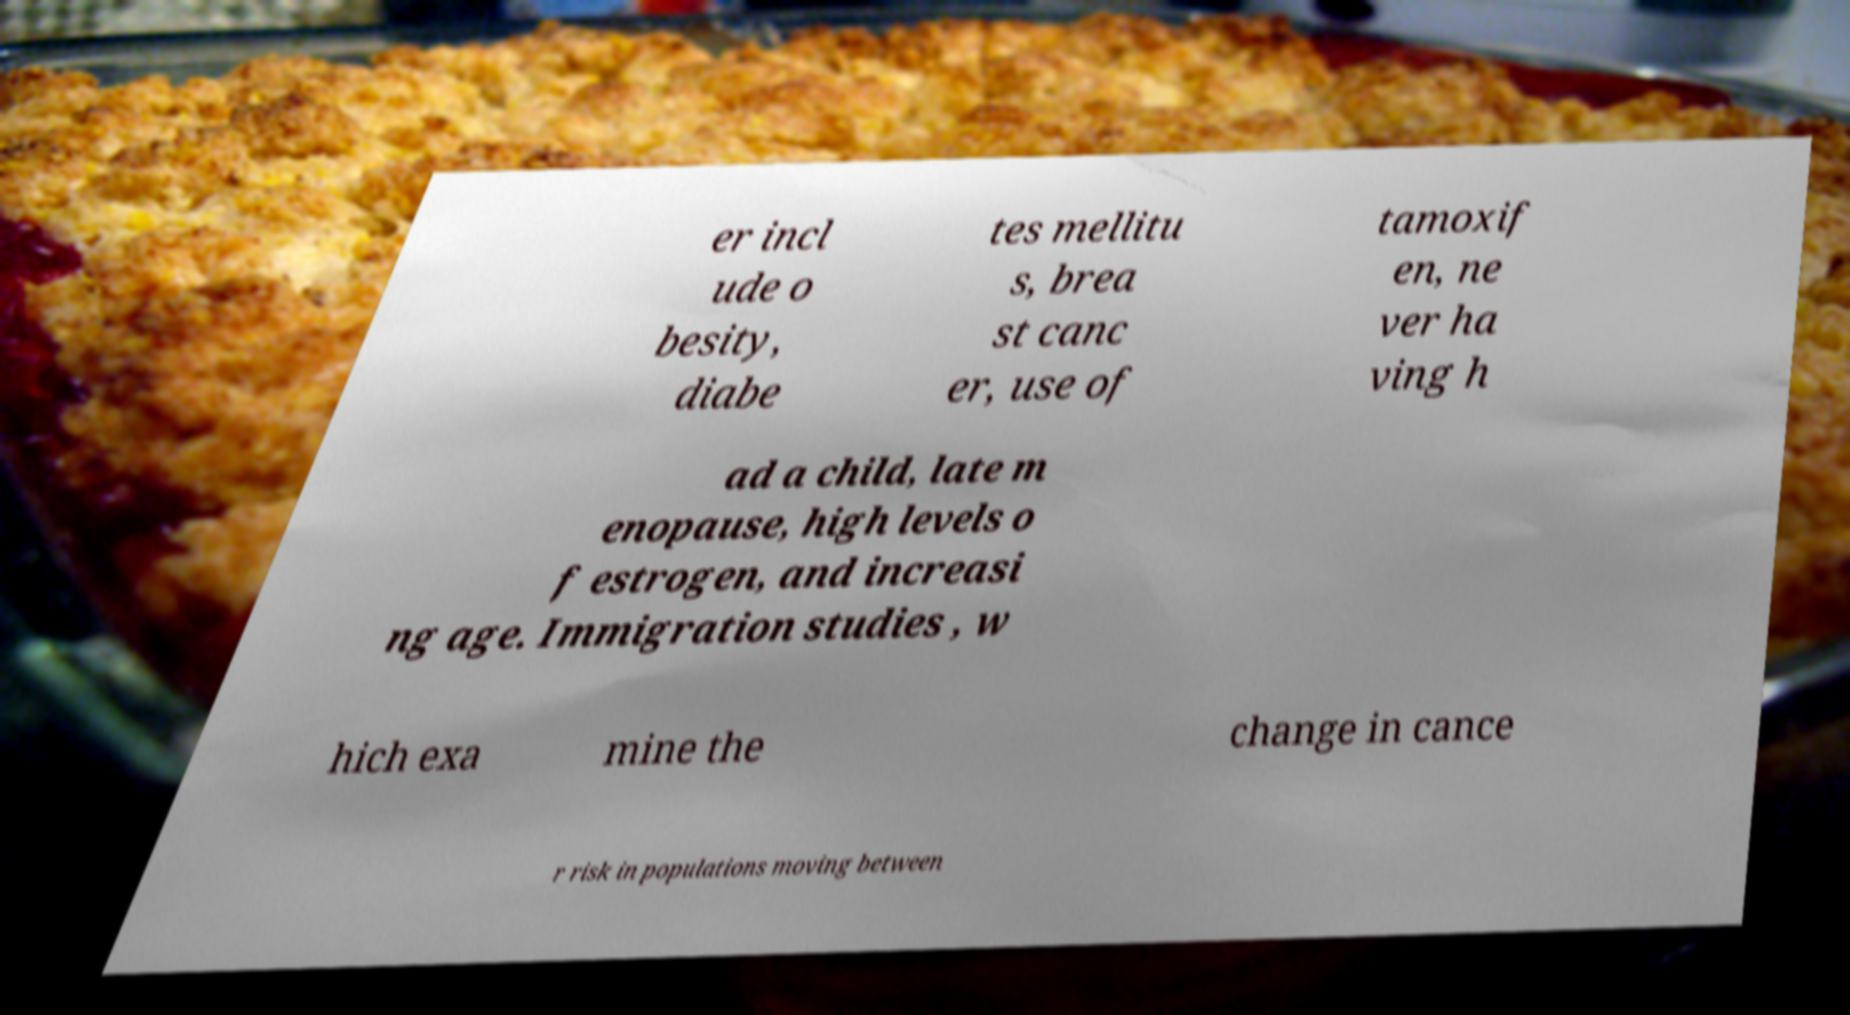Can you read and provide the text displayed in the image?This photo seems to have some interesting text. Can you extract and type it out for me? er incl ude o besity, diabe tes mellitu s, brea st canc er, use of tamoxif en, ne ver ha ving h ad a child, late m enopause, high levels o f estrogen, and increasi ng age. Immigration studies , w hich exa mine the change in cance r risk in populations moving between 